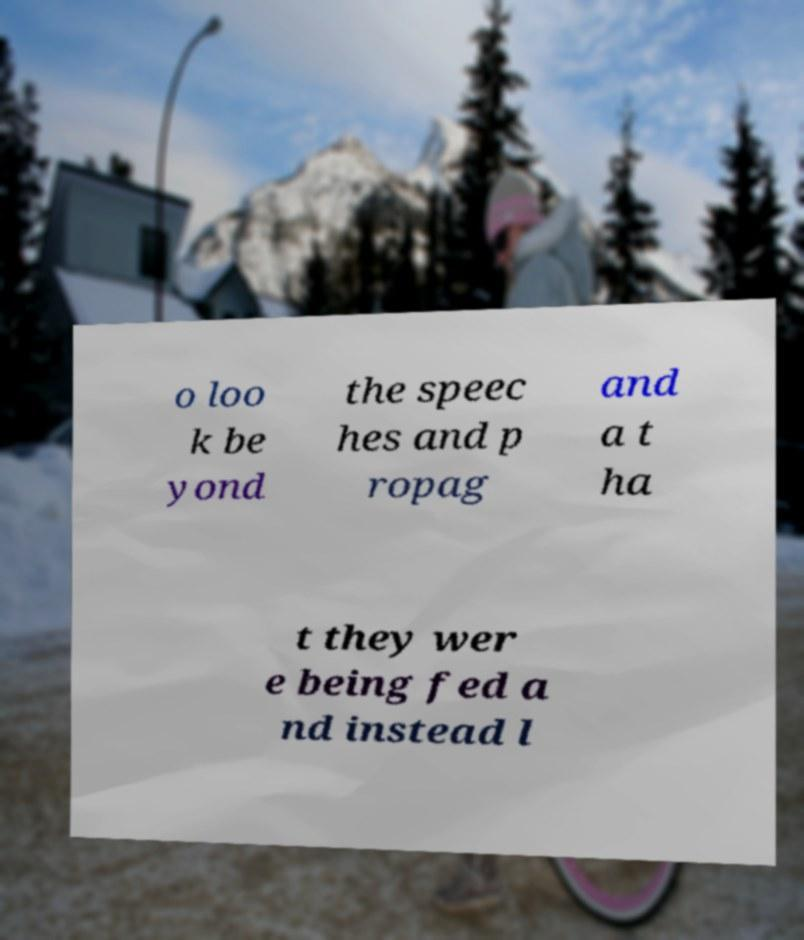There's text embedded in this image that I need extracted. Can you transcribe it verbatim? o loo k be yond the speec hes and p ropag and a t ha t they wer e being fed a nd instead l 